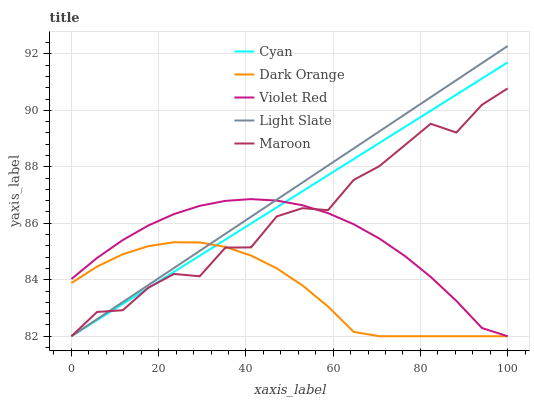Does Dark Orange have the minimum area under the curve?
Answer yes or no. Yes. Does Light Slate have the maximum area under the curve?
Answer yes or no. Yes. Does Cyan have the minimum area under the curve?
Answer yes or no. No. Does Cyan have the maximum area under the curve?
Answer yes or no. No. Is Cyan the smoothest?
Answer yes or no. Yes. Is Maroon the roughest?
Answer yes or no. Yes. Is Violet Red the smoothest?
Answer yes or no. No. Is Violet Red the roughest?
Answer yes or no. No. Does Light Slate have the lowest value?
Answer yes or no. Yes. Does Light Slate have the highest value?
Answer yes or no. Yes. Does Cyan have the highest value?
Answer yes or no. No. Does Light Slate intersect Dark Orange?
Answer yes or no. Yes. Is Light Slate less than Dark Orange?
Answer yes or no. No. Is Light Slate greater than Dark Orange?
Answer yes or no. No. 